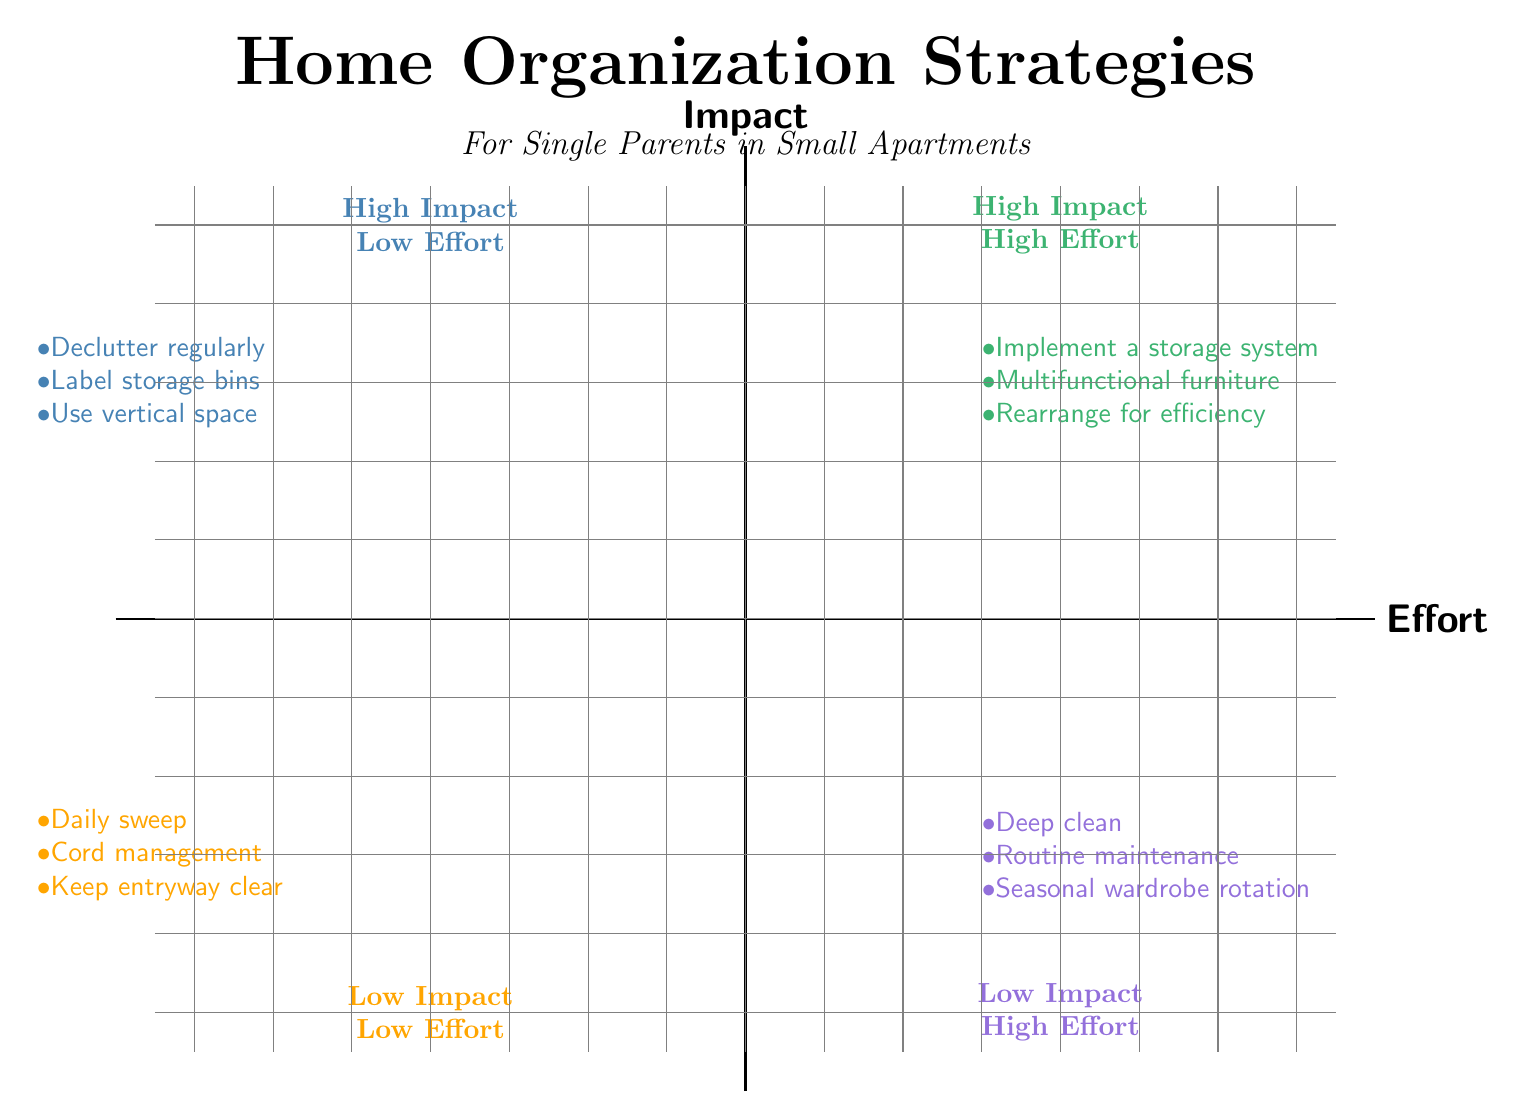What strategies fall under High Impact Low Effort? The diagram specifies three strategies in the High Impact Low Effort quadrant: declutter regularly, label storage bins, and use vertical space.
Answer: Declutter regularly, label storage bins, use vertical space How many strategies are listed in the Low Impact High Effort quadrant? There are three strategies provided in the Low Impact High Effort quadrant as shown in the diagram: deep clean, routine maintenance, and seasonal wardrobe rotation.
Answer: Three Which quadrant contains the strategy 'multifunctional furniture'? The strategy 'multifunctional furniture' is located in the High Impact High Effort quadrant according to the diagram.
Answer: High Impact High Effort What does the diagram suggest for Low Impact Low Effort maintenance? In the Low Impact Low Effort quadrant, daily sweep, cord management, and keep entryway clear are identified as maintenance strategies.
Answer: Daily sweep, cord management, keep entryway clear Which strategies involve high effort but have low impact? The strategies listed in the Low Impact High Effort quadrant include deep clean, routine maintenance, and seasonal wardrobe rotation, all of which require significant effort with minimal immediate impact.
Answer: Deep clean, routine maintenance, seasonal wardrobe rotation Why might a single parent prioritize 'declutter regularly' over 'deep clean'? 'Declutter regularly' has a high impact with low effort, making it easier to implement daily, while 'deep clean' entails a high effort for low impact, which can be overwhelming and less practical for busy parents.
Answer: Prioritize declutter regularly How does the number of strategies differ between High Impact Low Effort and Low Impact Low Effort? Both quadrants have the same number of strategies, with three strategies each listed, demonstrating a balance between high and low effort in the context of both impact types.
Answer: Same number, three each What is the primary focus of the strategies in the High Impact High Effort quadrant? The strategies in this quadrant are focused on implementing extensive changes such as storage systems and multifunctional furniture to create a more organized living space despite requiring more effort.
Answer: Storage systems and multifunctional furniture What should be done to maintain a clear entryway according to the diagram? The diagram suggests using a small tray or basket for keys and mail to keep the entryway organized and free from clutter.
Answer: Use a small tray or basket for keys and mail 